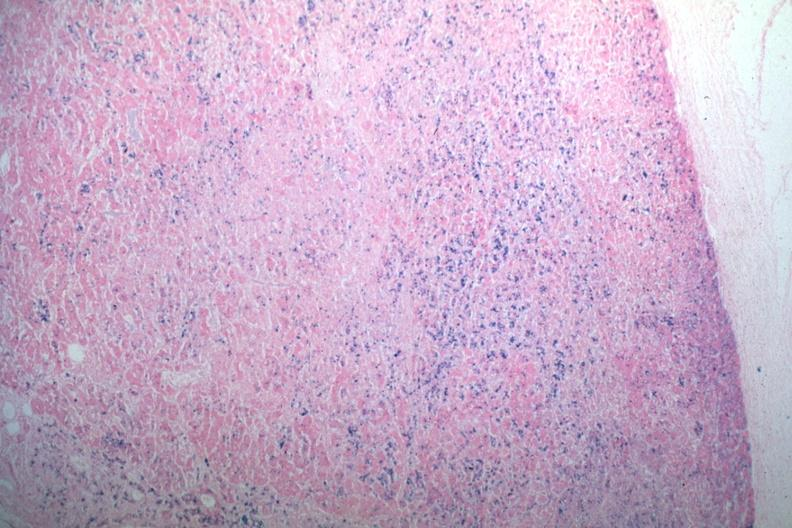how does iron stain iron?
Answer the question using a single word or phrase. Abundant 